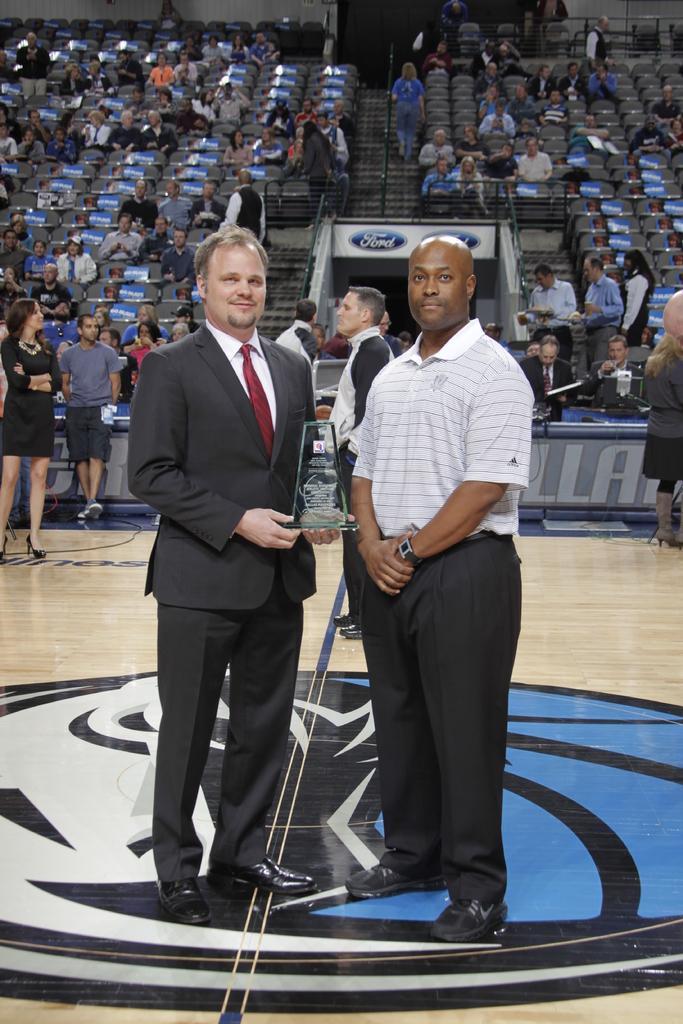Please provide a concise description of this image. In this image there are people standing on a floor and one man is holding an award in his hand, in the background there are people sitting on chairs. 